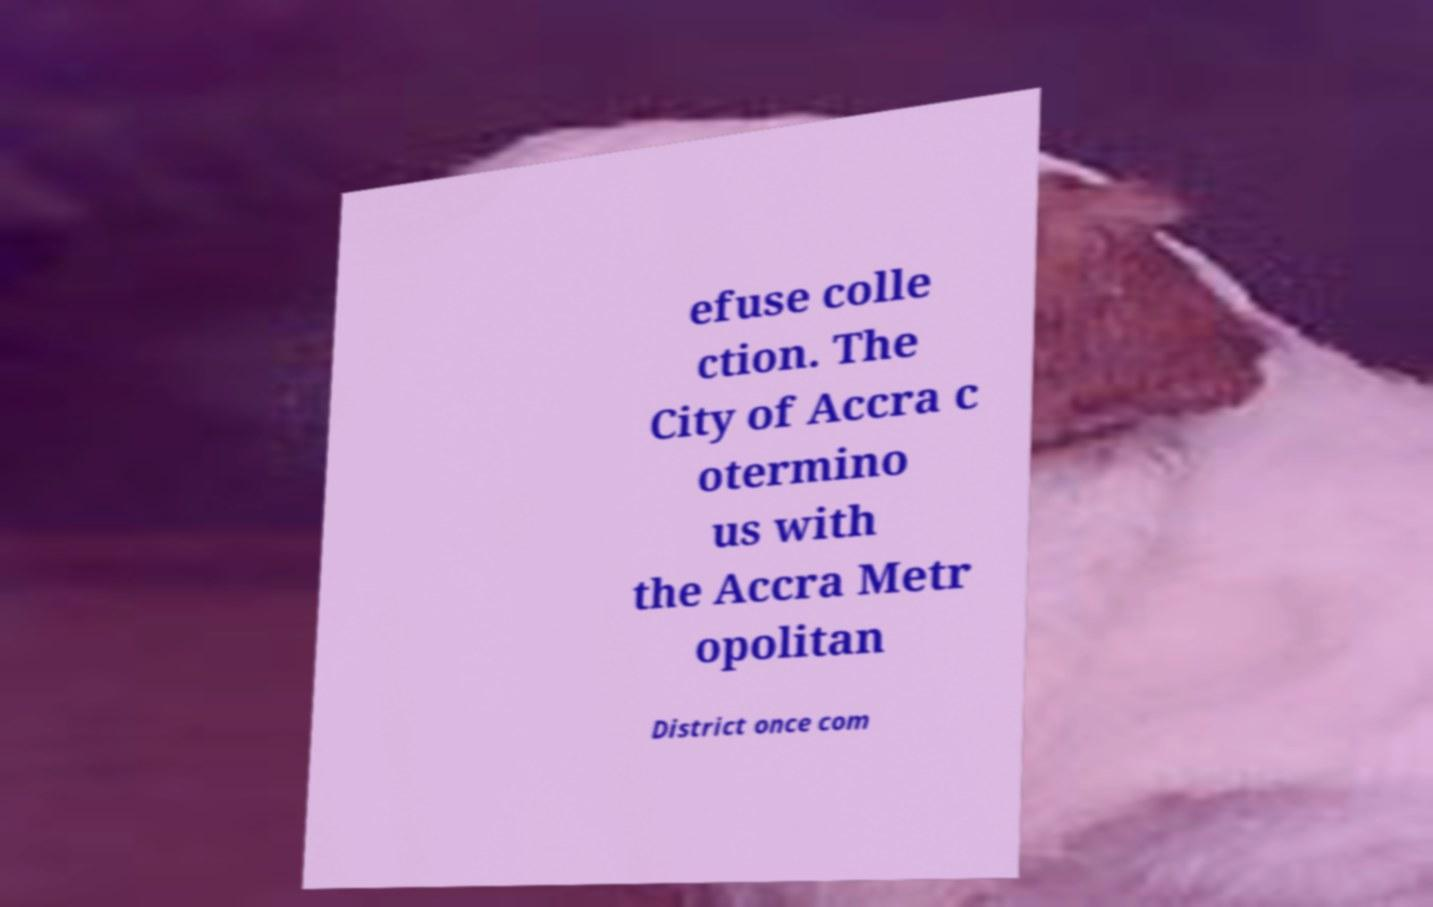Please identify and transcribe the text found in this image. efuse colle ction. The City of Accra c otermino us with the Accra Metr opolitan District once com 